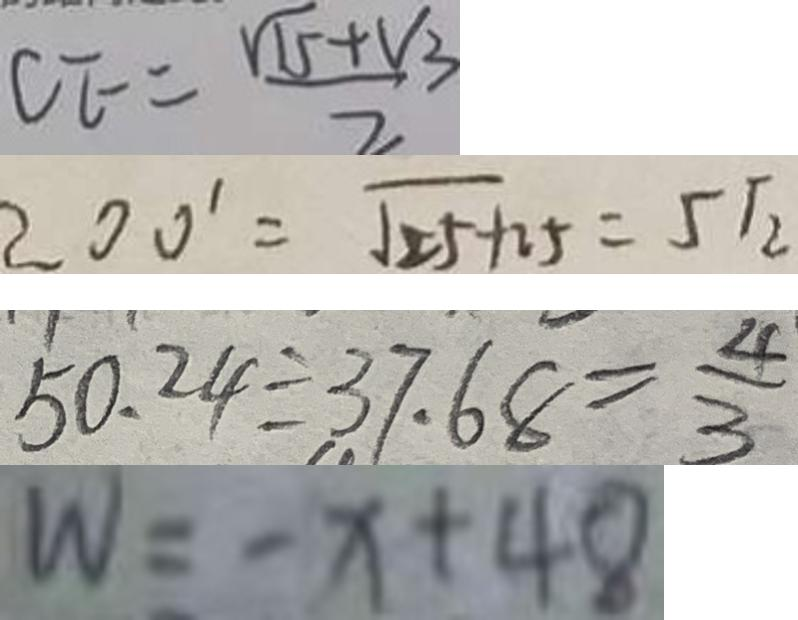Convert formula to latex. <formula><loc_0><loc_0><loc_500><loc_500>C E = \frac { \sqrt { 1 5 } + V _ { 3 } } { 2 } 
 2 0 0 ^ { \prime } = \sqrt { 2 5 + 2 5 } = 5 \sqrt { 2 } 
 5 0 . 2 4 \div 3 7 . 6 8 = \frac { 4 } { 3 } 
 W = - x + 4 8</formula> 